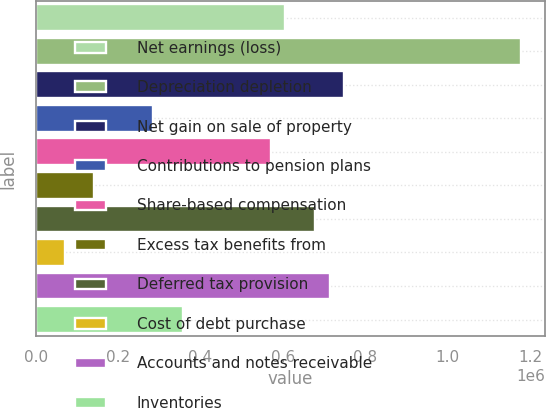Convert chart to OTSL. <chart><loc_0><loc_0><loc_500><loc_500><bar_chart><fcel>Net earnings (loss)<fcel>Depreciation depletion<fcel>Net gain on sale of property<fcel>Contributions to pension plans<fcel>Share-based compensation<fcel>Excess tax benefits from<fcel>Deferred tax provision<fcel>Cost of debt purchase<fcel>Accounts and notes receivable<fcel>Inventories<nl><fcel>606048<fcel>1.17645e+06<fcel>748648<fcel>285199<fcel>570398<fcel>142600<fcel>677348<fcel>71299.9<fcel>712998<fcel>356499<nl></chart> 